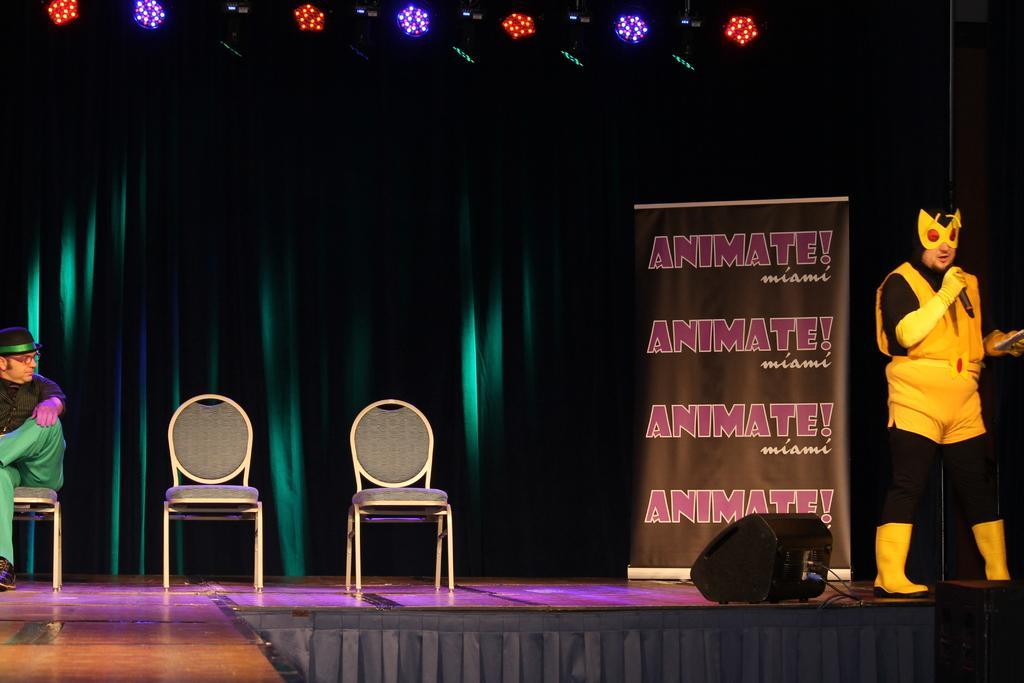Could you give a brief overview of what you see in this image? In this image, there is a stage. There is a person on the left side of the image sitting on the chair and wearing clothes, hat and footwear. There is an another person on the right side of the image holding a mic with his hand. There is a banner behind this person. There are two chairs between these two person. There are some lights at the top. 